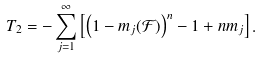<formula> <loc_0><loc_0><loc_500><loc_500>T _ { 2 } = - \sum _ { j = 1 } ^ { \infty } \left [ \left ( 1 - m _ { j } ( \mathcal { F } ) \right ) ^ { n } - 1 + n m _ { j } \right ] .</formula> 